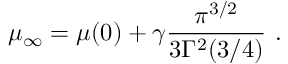<formula> <loc_0><loc_0><loc_500><loc_500>\mu _ { \infty } = \mu ( 0 ) + \gamma \frac { \pi ^ { 3 / 2 } } { 3 \Gamma ^ { 2 } ( 3 / 4 ) } \ .</formula> 